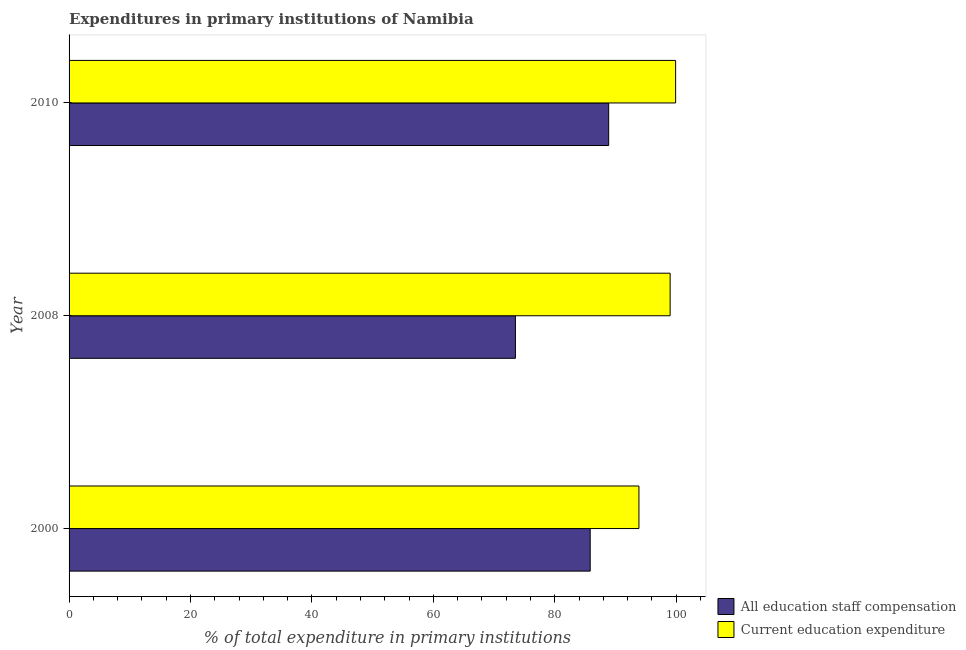How many groups of bars are there?
Ensure brevity in your answer.  3. Are the number of bars on each tick of the Y-axis equal?
Make the answer very short. Yes. How many bars are there on the 3rd tick from the bottom?
Offer a terse response. 2. What is the label of the 2nd group of bars from the top?
Provide a short and direct response. 2008. In how many cases, is the number of bars for a given year not equal to the number of legend labels?
Your answer should be compact. 0. What is the expenditure in education in 2008?
Your answer should be compact. 98.99. Across all years, what is the maximum expenditure in staff compensation?
Your answer should be very brief. 88.87. Across all years, what is the minimum expenditure in education?
Keep it short and to the point. 93.85. What is the total expenditure in education in the graph?
Offer a terse response. 292.73. What is the difference between the expenditure in education in 2000 and that in 2010?
Your answer should be compact. -6.04. What is the difference between the expenditure in staff compensation in 2008 and the expenditure in education in 2000?
Ensure brevity in your answer.  -20.34. What is the average expenditure in education per year?
Offer a terse response. 97.58. In the year 2000, what is the difference between the expenditure in education and expenditure in staff compensation?
Offer a terse response. 8.03. In how many years, is the expenditure in education greater than 84 %?
Offer a very short reply. 3. Is the difference between the expenditure in education in 2008 and 2010 greater than the difference between the expenditure in staff compensation in 2008 and 2010?
Make the answer very short. Yes. What is the difference between the highest and the second highest expenditure in education?
Provide a succinct answer. 0.9. What is the difference between the highest and the lowest expenditure in staff compensation?
Ensure brevity in your answer.  15.36. In how many years, is the expenditure in staff compensation greater than the average expenditure in staff compensation taken over all years?
Provide a short and direct response. 2. What does the 1st bar from the top in 2000 represents?
Your response must be concise. Current education expenditure. What does the 2nd bar from the bottom in 2010 represents?
Offer a terse response. Current education expenditure. How many bars are there?
Provide a short and direct response. 6. Does the graph contain any zero values?
Offer a very short reply. No. Does the graph contain grids?
Provide a short and direct response. No. Where does the legend appear in the graph?
Offer a very short reply. Bottom right. How many legend labels are there?
Provide a succinct answer. 2. What is the title of the graph?
Your answer should be very brief. Expenditures in primary institutions of Namibia. Does "Public funds" appear as one of the legend labels in the graph?
Provide a succinct answer. No. What is the label or title of the X-axis?
Make the answer very short. % of total expenditure in primary institutions. What is the label or title of the Y-axis?
Offer a terse response. Year. What is the % of total expenditure in primary institutions of All education staff compensation in 2000?
Your response must be concise. 85.82. What is the % of total expenditure in primary institutions of Current education expenditure in 2000?
Offer a very short reply. 93.85. What is the % of total expenditure in primary institutions in All education staff compensation in 2008?
Offer a very short reply. 73.51. What is the % of total expenditure in primary institutions in Current education expenditure in 2008?
Keep it short and to the point. 98.99. What is the % of total expenditure in primary institutions of All education staff compensation in 2010?
Provide a short and direct response. 88.87. What is the % of total expenditure in primary institutions of Current education expenditure in 2010?
Keep it short and to the point. 99.89. Across all years, what is the maximum % of total expenditure in primary institutions of All education staff compensation?
Provide a succinct answer. 88.87. Across all years, what is the maximum % of total expenditure in primary institutions of Current education expenditure?
Give a very brief answer. 99.89. Across all years, what is the minimum % of total expenditure in primary institutions of All education staff compensation?
Your answer should be very brief. 73.51. Across all years, what is the minimum % of total expenditure in primary institutions of Current education expenditure?
Give a very brief answer. 93.85. What is the total % of total expenditure in primary institutions of All education staff compensation in the graph?
Your answer should be compact. 248.2. What is the total % of total expenditure in primary institutions in Current education expenditure in the graph?
Your response must be concise. 292.73. What is the difference between the % of total expenditure in primary institutions of All education staff compensation in 2000 and that in 2008?
Your answer should be compact. 12.31. What is the difference between the % of total expenditure in primary institutions of Current education expenditure in 2000 and that in 2008?
Give a very brief answer. -5.14. What is the difference between the % of total expenditure in primary institutions in All education staff compensation in 2000 and that in 2010?
Make the answer very short. -3.04. What is the difference between the % of total expenditure in primary institutions of Current education expenditure in 2000 and that in 2010?
Provide a succinct answer. -6.04. What is the difference between the % of total expenditure in primary institutions in All education staff compensation in 2008 and that in 2010?
Provide a succinct answer. -15.36. What is the difference between the % of total expenditure in primary institutions in Current education expenditure in 2008 and that in 2010?
Ensure brevity in your answer.  -0.9. What is the difference between the % of total expenditure in primary institutions in All education staff compensation in 2000 and the % of total expenditure in primary institutions in Current education expenditure in 2008?
Keep it short and to the point. -13.17. What is the difference between the % of total expenditure in primary institutions of All education staff compensation in 2000 and the % of total expenditure in primary institutions of Current education expenditure in 2010?
Your response must be concise. -14.07. What is the difference between the % of total expenditure in primary institutions in All education staff compensation in 2008 and the % of total expenditure in primary institutions in Current education expenditure in 2010?
Provide a succinct answer. -26.38. What is the average % of total expenditure in primary institutions in All education staff compensation per year?
Provide a short and direct response. 82.73. What is the average % of total expenditure in primary institutions in Current education expenditure per year?
Ensure brevity in your answer.  97.58. In the year 2000, what is the difference between the % of total expenditure in primary institutions in All education staff compensation and % of total expenditure in primary institutions in Current education expenditure?
Keep it short and to the point. -8.03. In the year 2008, what is the difference between the % of total expenditure in primary institutions in All education staff compensation and % of total expenditure in primary institutions in Current education expenditure?
Offer a very short reply. -25.48. In the year 2010, what is the difference between the % of total expenditure in primary institutions in All education staff compensation and % of total expenditure in primary institutions in Current education expenditure?
Keep it short and to the point. -11.03. What is the ratio of the % of total expenditure in primary institutions of All education staff compensation in 2000 to that in 2008?
Make the answer very short. 1.17. What is the ratio of the % of total expenditure in primary institutions in Current education expenditure in 2000 to that in 2008?
Make the answer very short. 0.95. What is the ratio of the % of total expenditure in primary institutions in All education staff compensation in 2000 to that in 2010?
Give a very brief answer. 0.97. What is the ratio of the % of total expenditure in primary institutions of Current education expenditure in 2000 to that in 2010?
Your answer should be very brief. 0.94. What is the ratio of the % of total expenditure in primary institutions of All education staff compensation in 2008 to that in 2010?
Your response must be concise. 0.83. What is the difference between the highest and the second highest % of total expenditure in primary institutions of All education staff compensation?
Your response must be concise. 3.04. What is the difference between the highest and the second highest % of total expenditure in primary institutions in Current education expenditure?
Make the answer very short. 0.9. What is the difference between the highest and the lowest % of total expenditure in primary institutions of All education staff compensation?
Ensure brevity in your answer.  15.36. What is the difference between the highest and the lowest % of total expenditure in primary institutions of Current education expenditure?
Offer a very short reply. 6.04. 